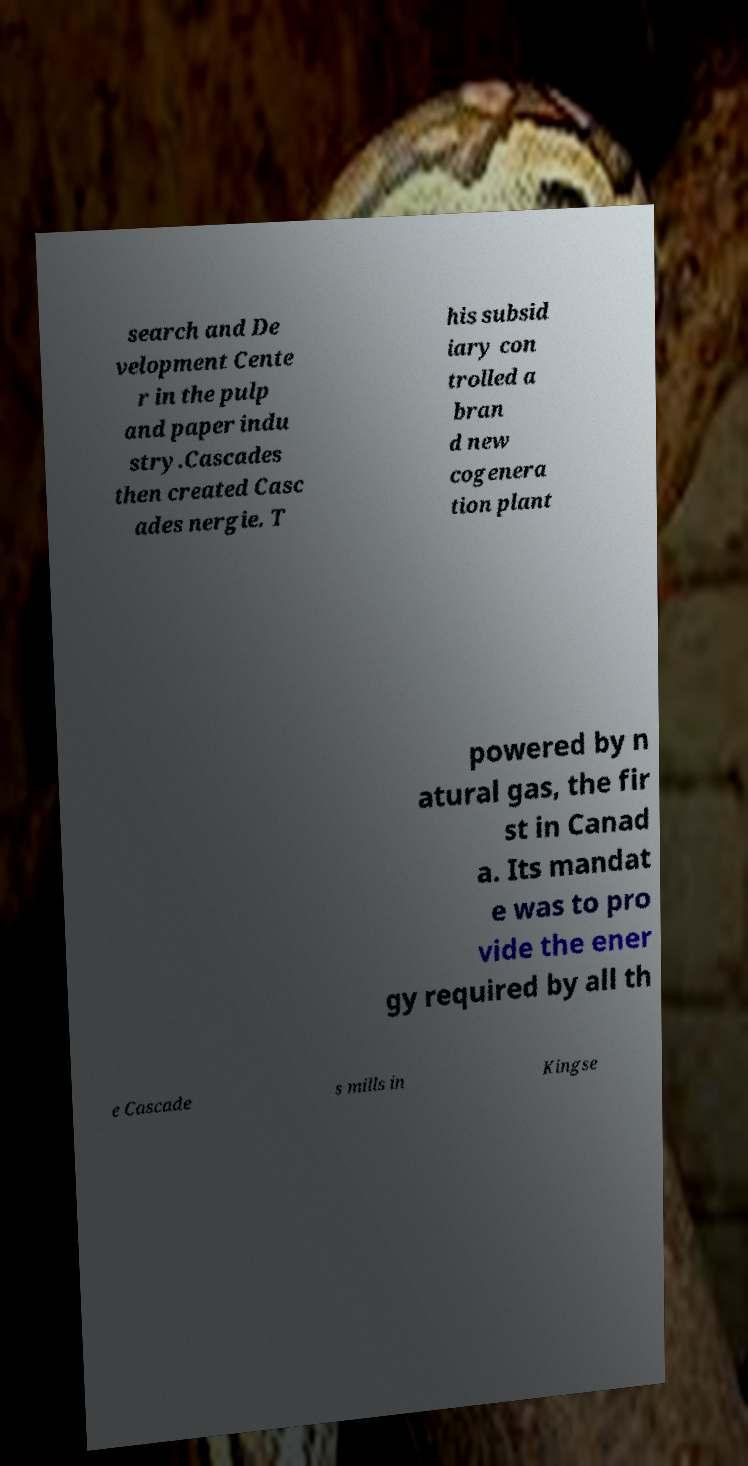What messages or text are displayed in this image? I need them in a readable, typed format. search and De velopment Cente r in the pulp and paper indu stry.Cascades then created Casc ades nergie. T his subsid iary con trolled a bran d new cogenera tion plant powered by n atural gas, the fir st in Canad a. Its mandat e was to pro vide the ener gy required by all th e Cascade s mills in Kingse 